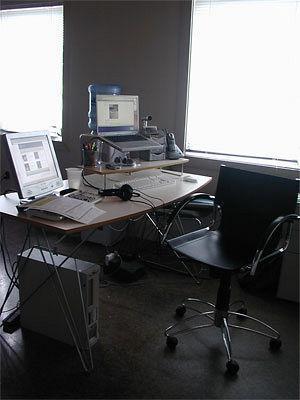How many laptops can be seen?
Give a very brief answer. 2. How many people are wearing black shorts?
Give a very brief answer. 0. 